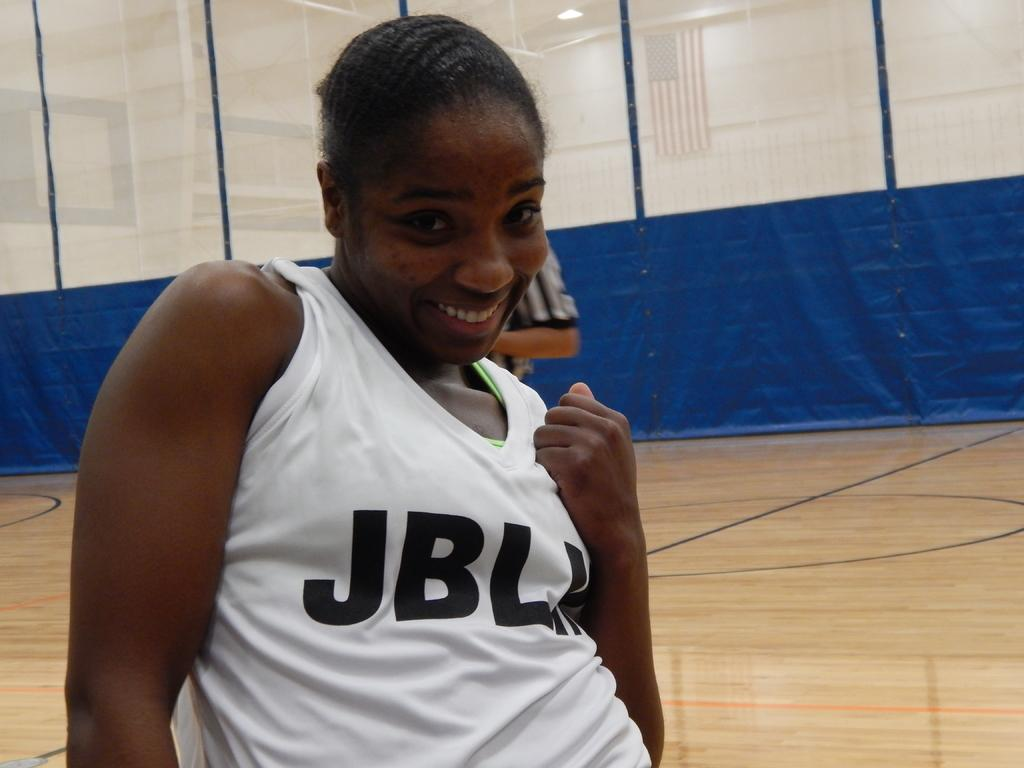<image>
Give a short and clear explanation of the subsequent image. Woman grinning at the camera wearing a JBL shirt with the sleeves pulled up over her shoulders. 